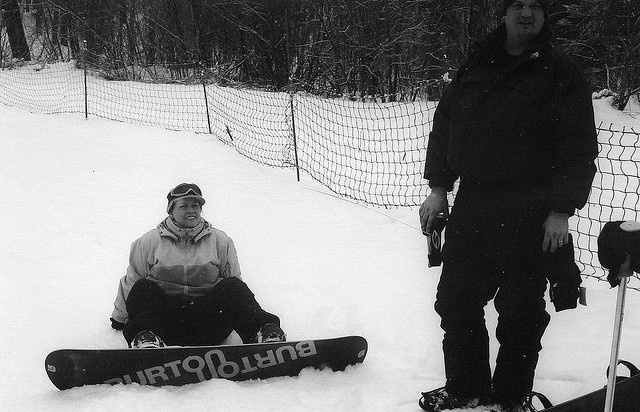Describe the objects in this image and their specific colors. I can see people in black, gray, lightgray, and darkgray tones, people in black, gray, darkgray, and lightgray tones, snowboard in black, gray, darkgray, and lightgray tones, and snowboard in black, gray, darkgray, and lightgray tones in this image. 